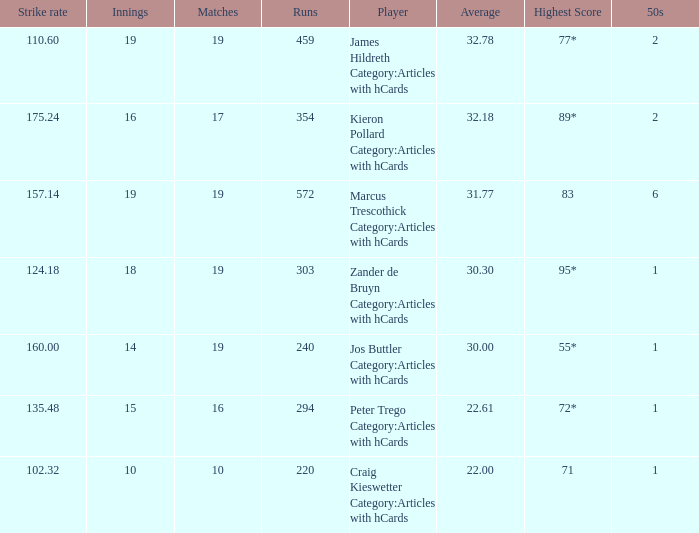What is the highest score for the player with average of 30.00? 55*. 